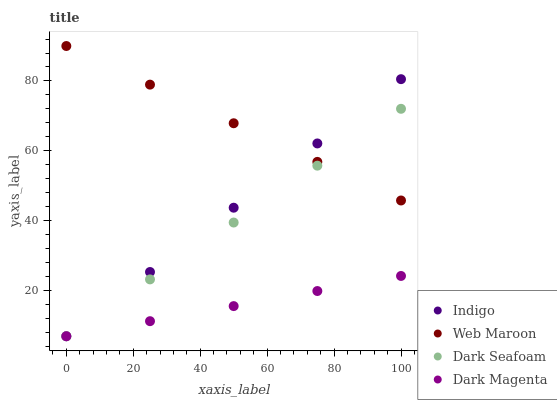Does Dark Magenta have the minimum area under the curve?
Answer yes or no. Yes. Does Web Maroon have the maximum area under the curve?
Answer yes or no. Yes. Does Dark Seafoam have the minimum area under the curve?
Answer yes or no. No. Does Dark Seafoam have the maximum area under the curve?
Answer yes or no. No. Is Dark Seafoam the smoothest?
Answer yes or no. Yes. Is Web Maroon the roughest?
Answer yes or no. Yes. Is Dark Magenta the roughest?
Answer yes or no. No. Does Dark Seafoam have the lowest value?
Answer yes or no. Yes. Does Web Maroon have the highest value?
Answer yes or no. Yes. Does Dark Seafoam have the highest value?
Answer yes or no. No. Is Dark Magenta less than Web Maroon?
Answer yes or no. Yes. Is Web Maroon greater than Dark Magenta?
Answer yes or no. Yes. Does Dark Seafoam intersect Dark Magenta?
Answer yes or no. Yes. Is Dark Seafoam less than Dark Magenta?
Answer yes or no. No. Is Dark Seafoam greater than Dark Magenta?
Answer yes or no. No. Does Dark Magenta intersect Web Maroon?
Answer yes or no. No. 